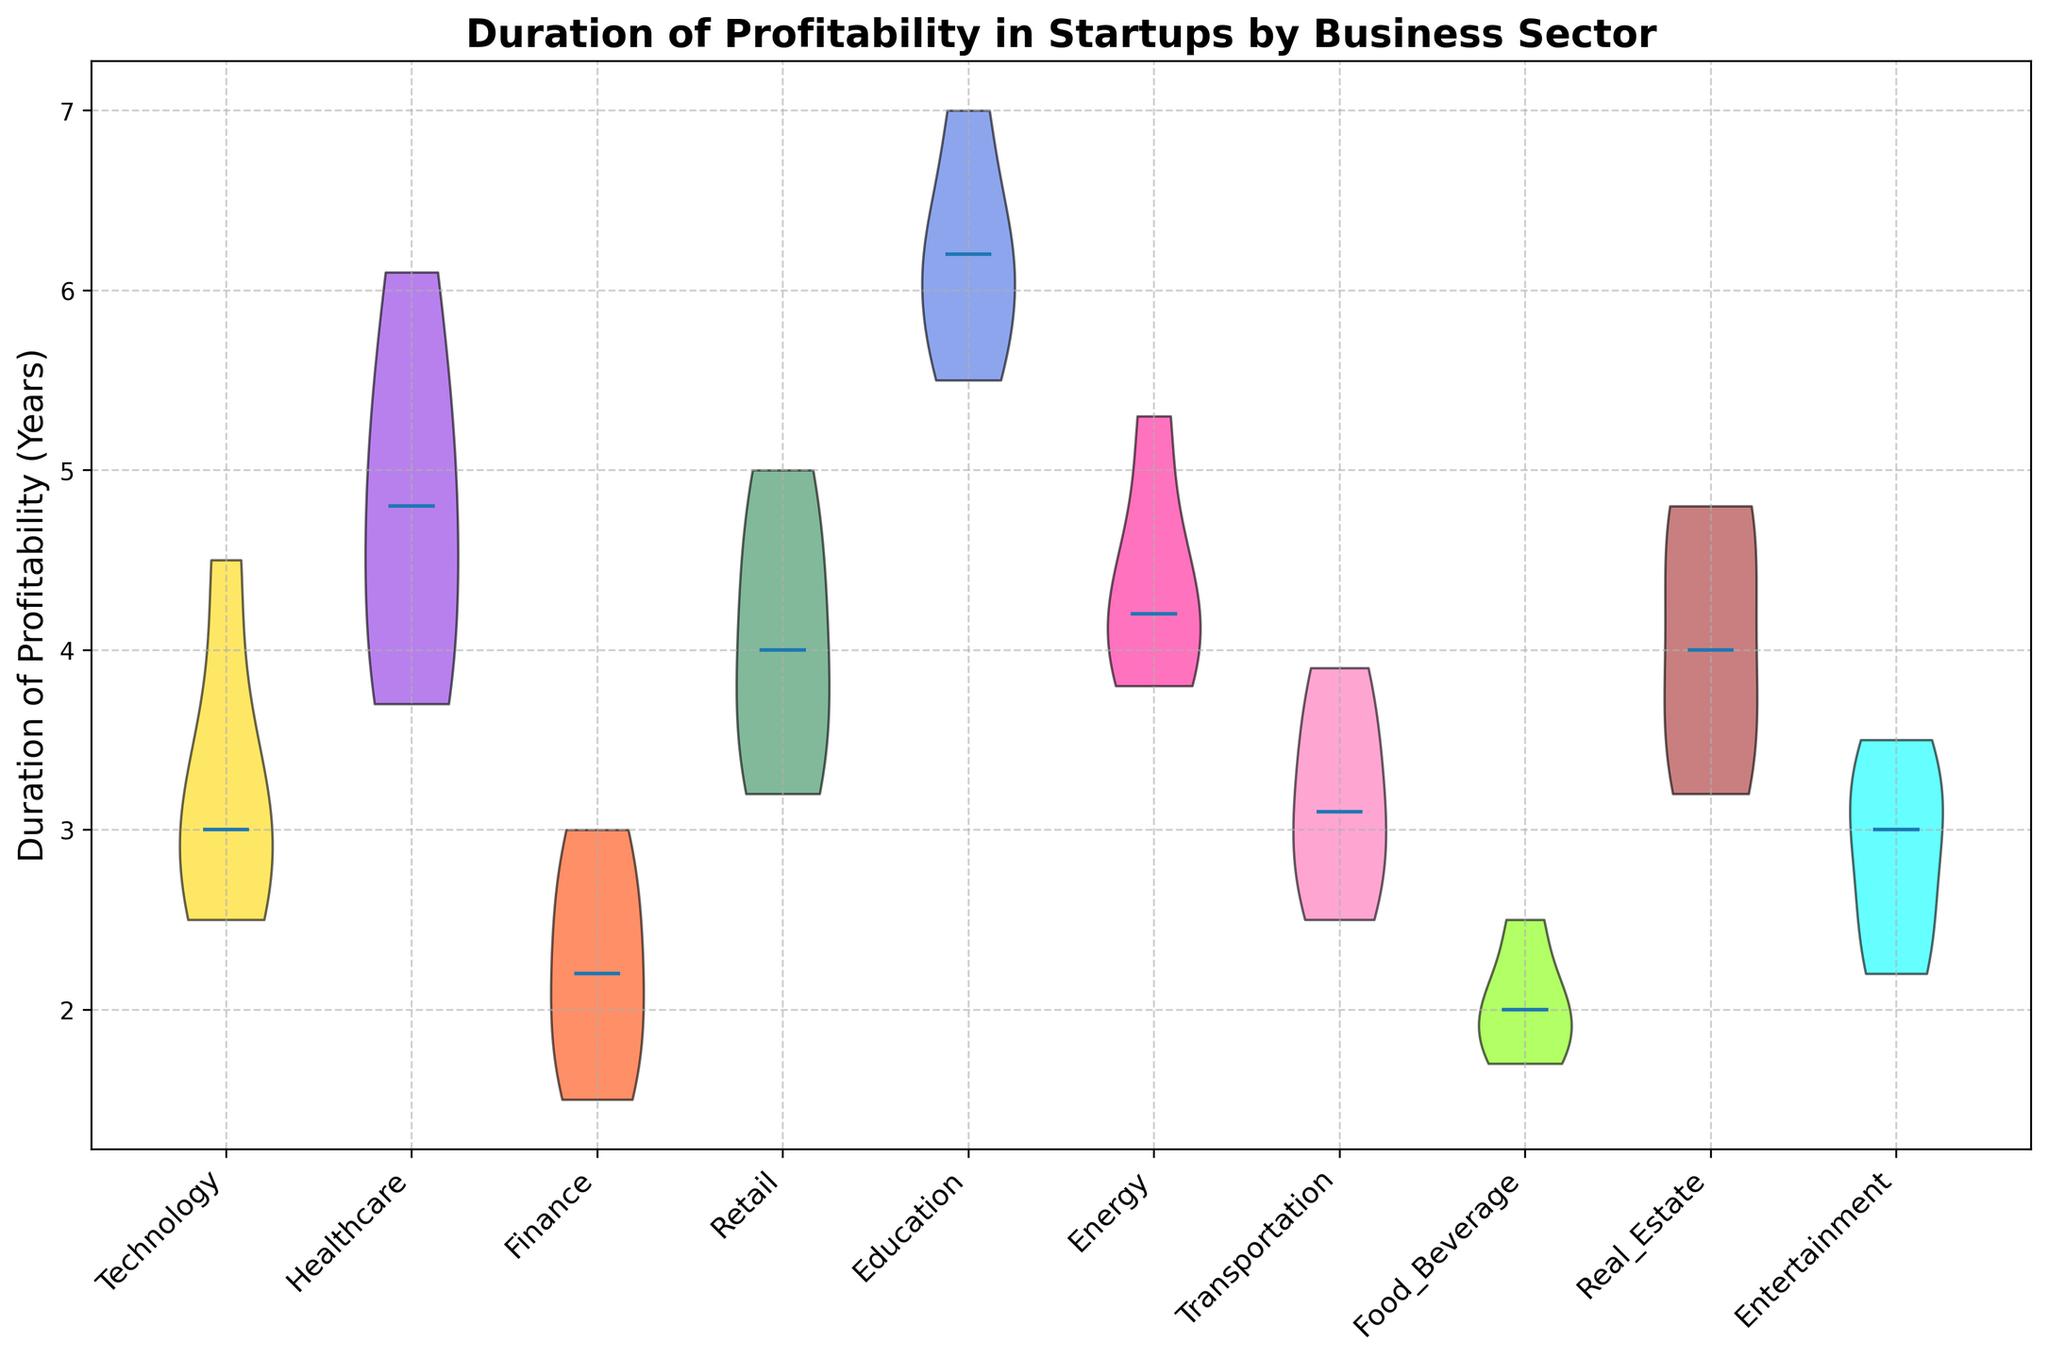What's the median duration of profitability for the Healthcare sector? To obtain the median duration of profitability for the Healthcare sector, observe the horizontal line within the shape of the violin plot for Healthcare. This line represents the median value.
Answer: 4.8 years Which sector has the highest median duration of profitability? Check the median lines across all sectors and identify which one has the highest position on the y-axis. The Education sector's median line is the highest.
Answer: Education How does the median duration of profitability in the Technology sector compare to that of the Finance sector? Compare the position of the median lines for both Technology and Finance sectors on the y-axis. The Technology sector has a higher median line than Finance, indicating a higher median duration of profitability.
Answer: Technology is higher Which sector shows the widest distribution in the duration of profitability? Examine the width of each violin plot. The wider the plot, the greater the distribution. The Retail sector appears to have one of the widest distributions.
Answer: Retail What is the approximate range of profitability durations for the Real Estate sector? Look at the vertical extent of the violin plot for the Real Estate sector. The range can be estimated from the lowest to the highest points in the plot. Approximately, it ranges from 3.2 to 4.8 years.
Answer: 3.2 to 4.8 years Is there any sector where the median duration of profitability is exactly in the middle of the range? Check if any sector's median line divides the violin plot into two equal parts vertically. In the Food & Beverage sector, the median line is exactly in the middle.
Answer: Food & Beverage Which sector has the most tightly packed duration of profitability values? Identify the narrowest violin plot on the chart, indicating a tightly packed distribution. The Energy sector has one of the most tightly packed distributions.
Answer: Energy What color represents the Entertainment sector in this plot? Note the color of the body of the violin plot corresponding to the sector labels on the x-axis. The Entertainment sector is represented by a cyan or blueish color.
Answer: Cyan 